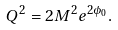Convert formula to latex. <formula><loc_0><loc_0><loc_500><loc_500>Q ^ { 2 } = 2 M ^ { 2 } e ^ { 2 \phi _ { 0 } } .</formula> 